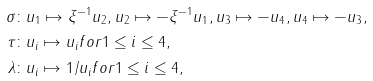Convert formula to latex. <formula><loc_0><loc_0><loc_500><loc_500>\sigma \colon & u _ { 1 } \mapsto \xi ^ { - 1 } u _ { 2 } , u _ { 2 } \mapsto - \xi ^ { - 1 } u _ { 1 } , u _ { 3 } \mapsto - u _ { 4 } , u _ { 4 } \mapsto - u _ { 3 } , \\ \tau \colon & u _ { i } \mapsto u _ { i } f o r 1 \leq i \leq 4 , \\ \lambda \colon & u _ { i } \mapsto 1 / u _ { i } f o r 1 \leq i \leq 4 ,</formula> 